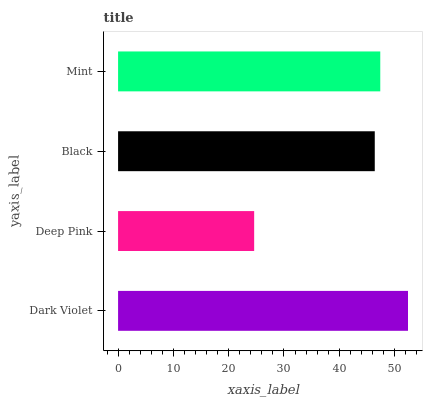Is Deep Pink the minimum?
Answer yes or no. Yes. Is Dark Violet the maximum?
Answer yes or no. Yes. Is Black the minimum?
Answer yes or no. No. Is Black the maximum?
Answer yes or no. No. Is Black greater than Deep Pink?
Answer yes or no. Yes. Is Deep Pink less than Black?
Answer yes or no. Yes. Is Deep Pink greater than Black?
Answer yes or no. No. Is Black less than Deep Pink?
Answer yes or no. No. Is Mint the high median?
Answer yes or no. Yes. Is Black the low median?
Answer yes or no. Yes. Is Dark Violet the high median?
Answer yes or no. No. Is Mint the low median?
Answer yes or no. No. 